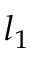Convert formula to latex. <formula><loc_0><loc_0><loc_500><loc_500>l _ { 1 }</formula> 